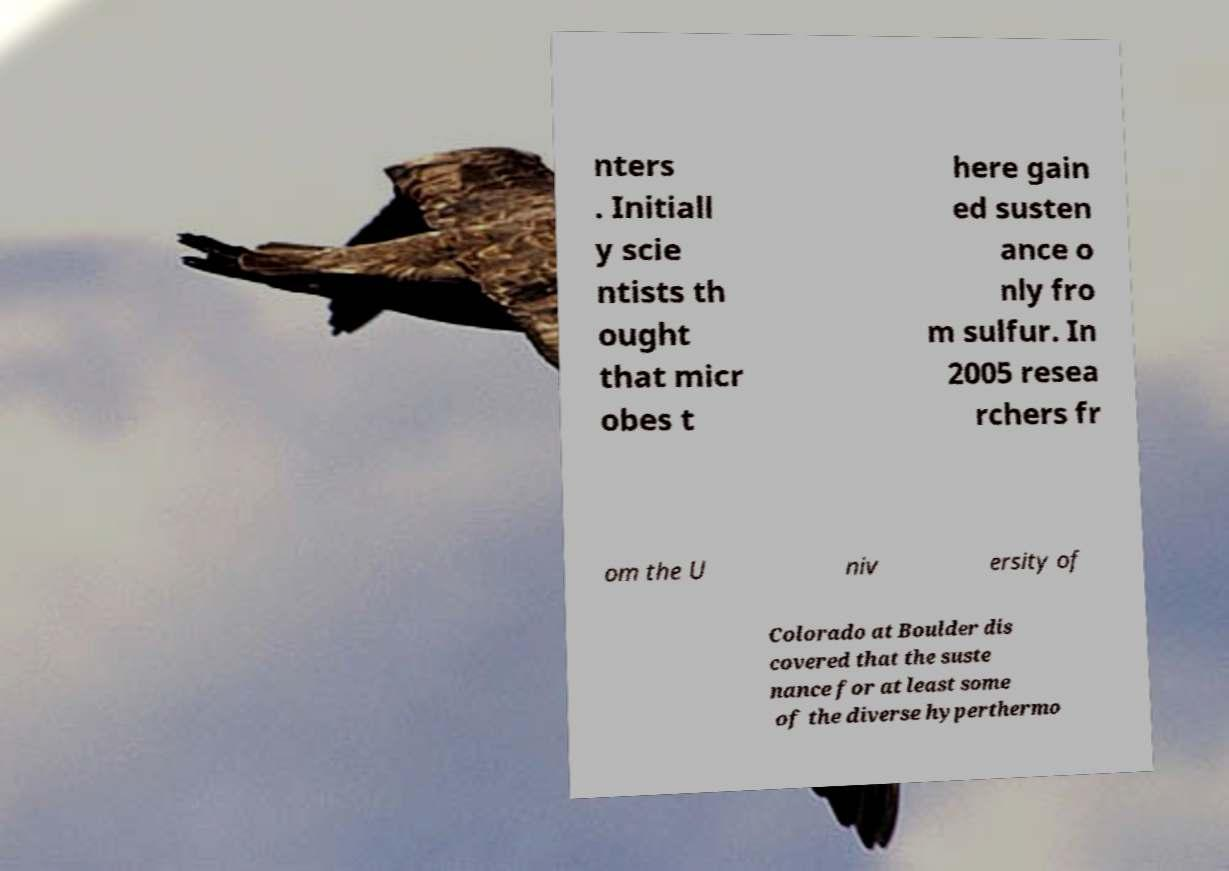Can you accurately transcribe the text from the provided image for me? nters . Initiall y scie ntists th ought that micr obes t here gain ed susten ance o nly fro m sulfur. In 2005 resea rchers fr om the U niv ersity of Colorado at Boulder dis covered that the suste nance for at least some of the diverse hyperthermo 